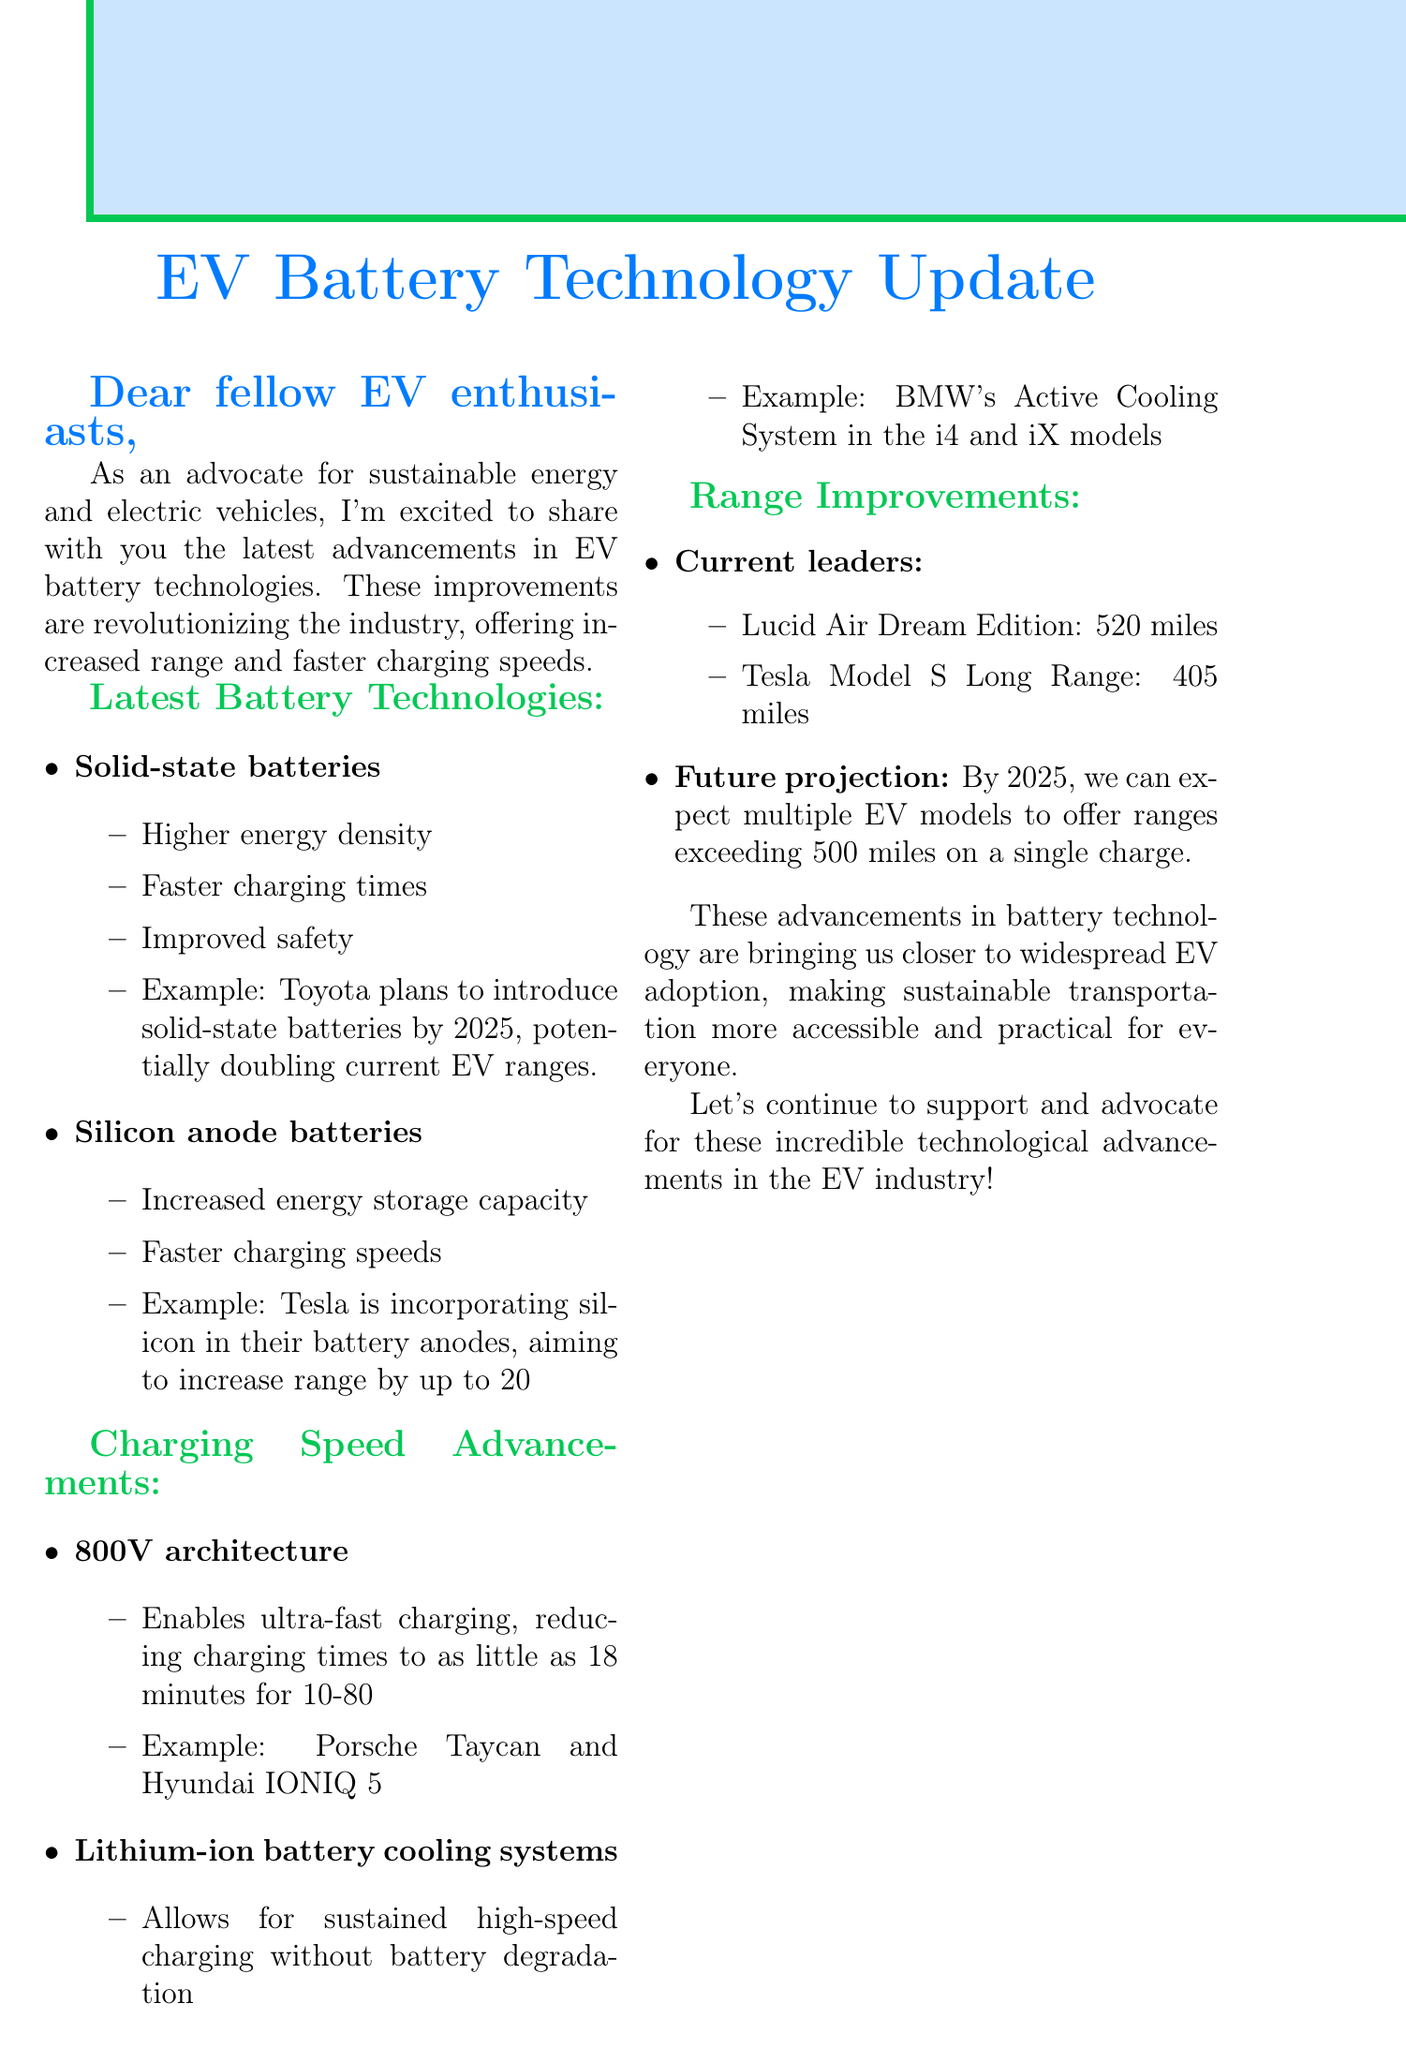What is the name of the first battery technology mentioned? The document states that the first battery technology mentioned is "Solid-state batteries."
Answer: Solid-state batteries What is one advantage of silicon anode batteries? One of the advantages listed for silicon anode batteries is "Increased energy storage capacity."
Answer: Increased energy storage capacity What is the range of the Lucid Air Dream Edition? The document indicates that the Lucid Air Dream Edition has a range of "520 miles."
Answer: 520 miles What technology reduces charging times to as little as 18 minutes? The document states that "800V architecture" enables ultra-fast charging, reducing charging times.
Answer: 800V architecture By what year does Toyota plan to introduce solid-state batteries? The document mentions that Toyota plans to introduce solid-state batteries by the year "2025."
Answer: 2025 How much range increase does Tesla aim for with silicon anode batteries? Tesla aims to increase range by "up to 20%" with silicon anode batteries according to the document.
Answer: up to 20% What is the range of the Tesla Model S Long Range? The Tesla Model S Long Range has a range of "405 miles" as mentioned in the document.
Answer: 405 miles What is the main theme of the document? The main theme is advancements in EV battery technologies, focusing on range and charging speeds.
Answer: Advancements in EV battery technologies What does Sam Evans encourage readers to do at the end of the document? Sam Evans encourages readers to "support and advocate for" advancements in the EV industry.
Answer: Support and advocate for advancements in the EV industry 